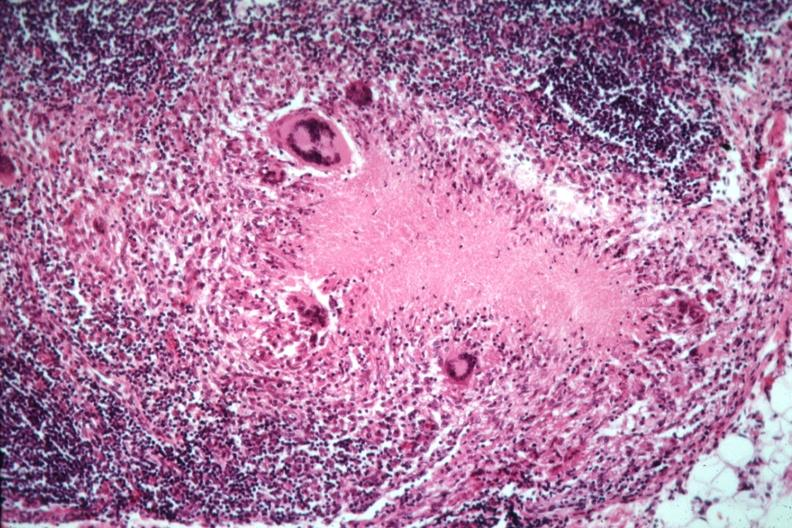what is present?
Answer the question using a single word or phrase. Tuberculosis 